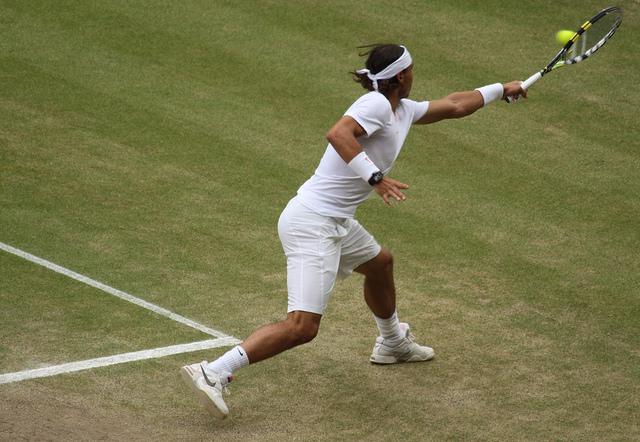What color is the ball?
Concise answer only. Yellow. What do you call her style of socks?
Give a very brief answer. Crew. Is it a man or a woman?
Short answer required. Man. What says nike?
Write a very short answer. Shoes. Did she hit the ball?
Short answer required. Yes. 